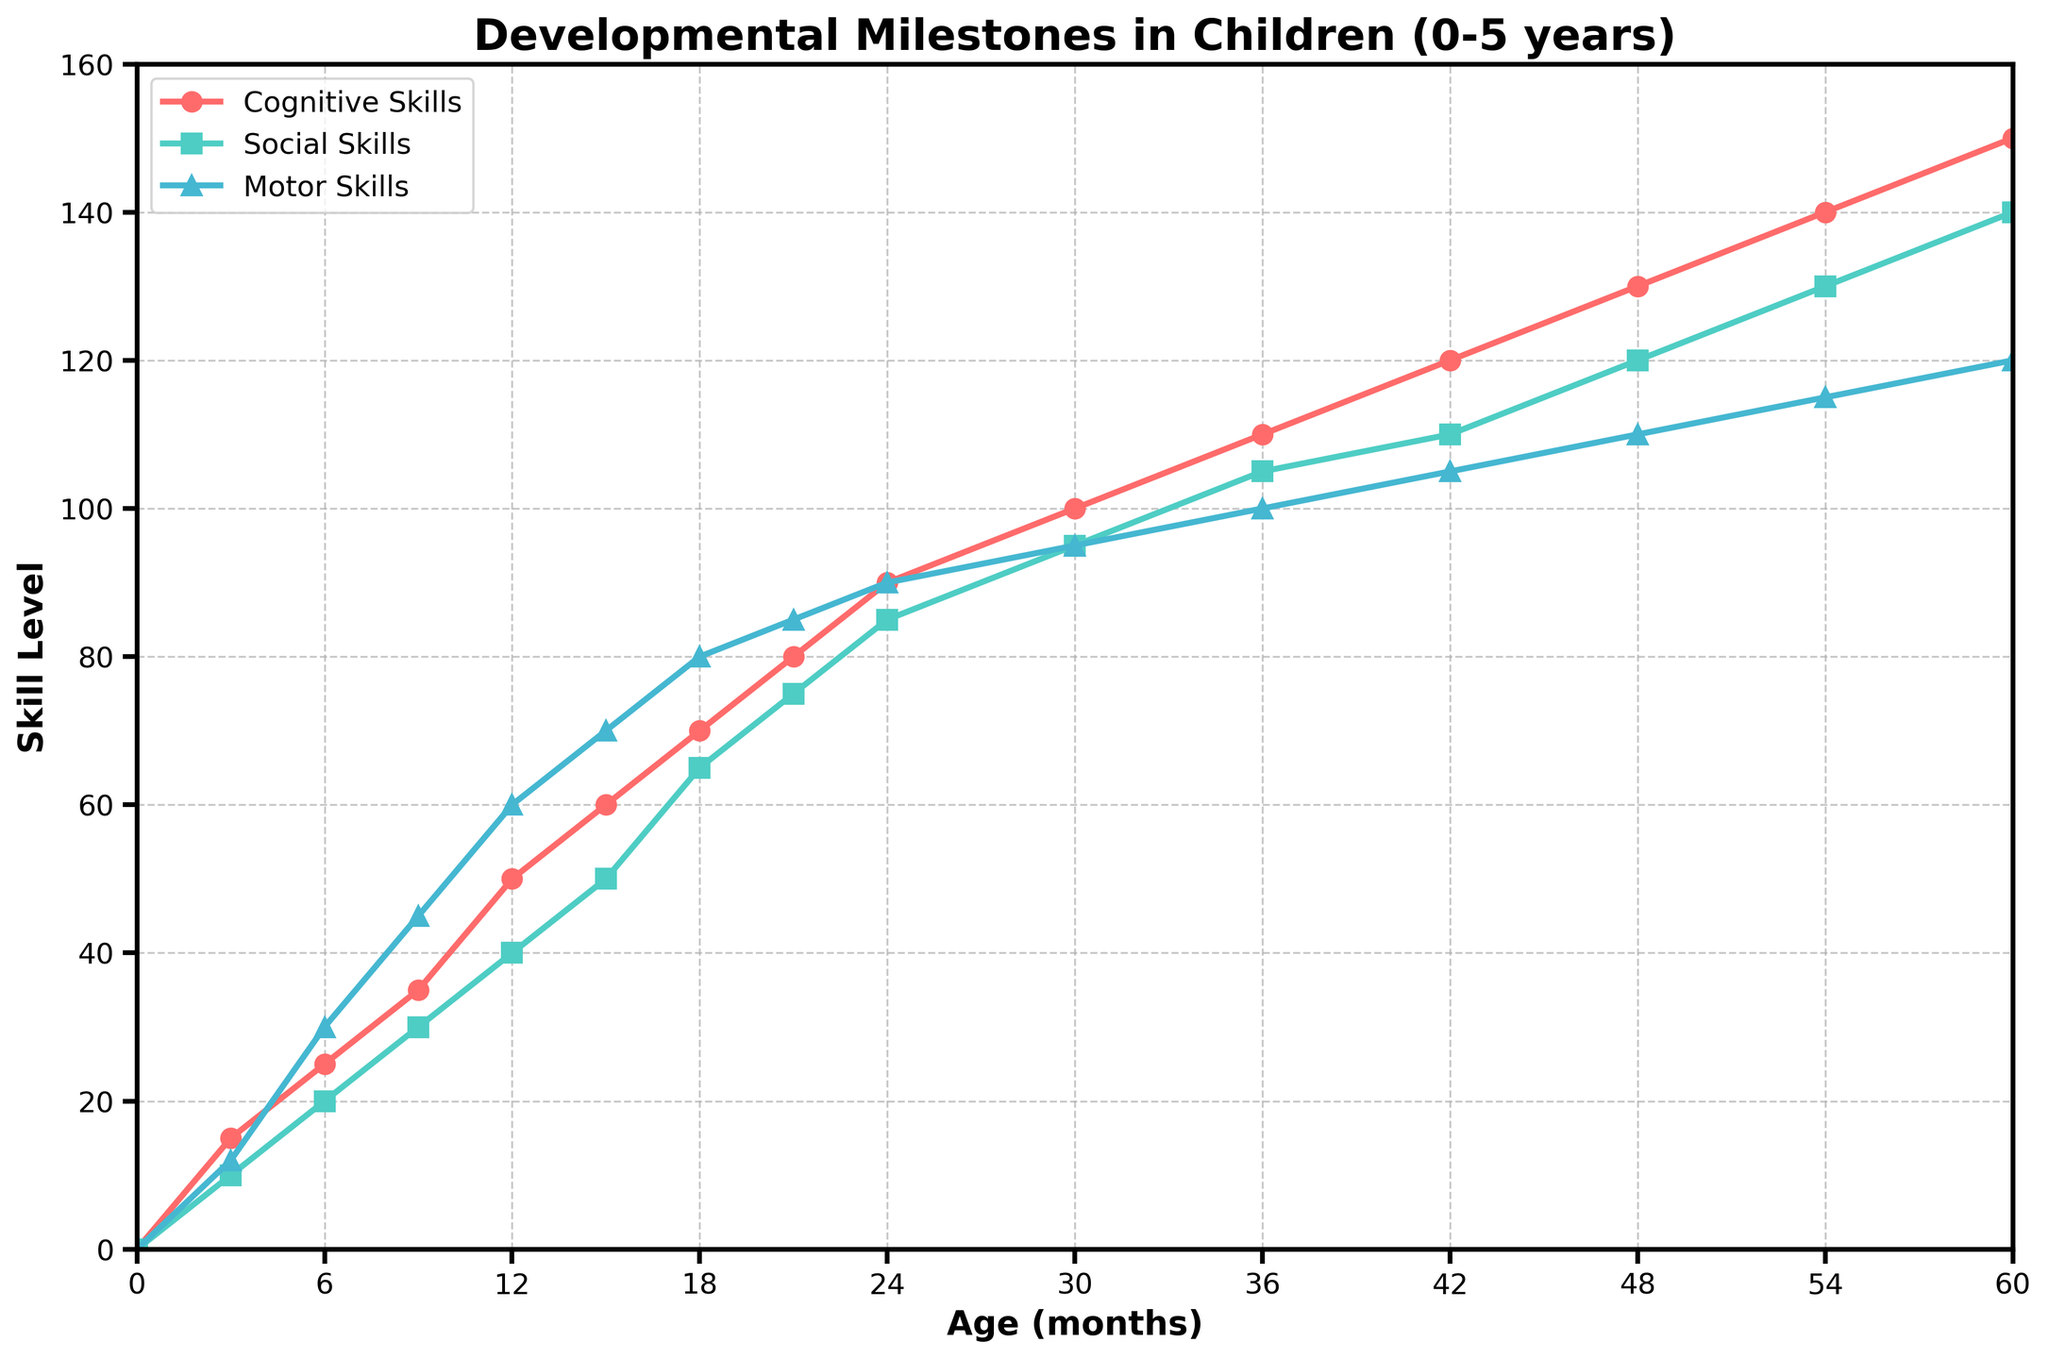What is the skill level of cognitive skills at 24 months? At 24 months, the skill level for cognitive skills can be identified on the y-axis where the line labeled "Cognitive Skills" intersects the 24-month mark on the x-axis.
Answer: 90 How much higher is the cognitive skill level compared to the motor skill level at 54 months? First, identify the cognitive skill level at 54 months (140) and the motor skill level at 54 months (115). Then subtract the motor skill level from the cognitive skill level: 140 - 115 = 25.
Answer: 25 Which skill shows the greatest increase between 12 and 24 months? Find the increase for each skill between 12 and 24 months. Cognitive Skills: 90 - 50 = 40; Social Skills: 85 - 40 = 45; Motor Skills: 90 - 60 = 30. Social skills increased the most by 45 units.
Answer: Social Skills Between which ages does the motor skill level first reach 100? Identify where the motor skills line first intersects the 100 level on the y-axis. It occurs at 36 months.
Answer: 36 months By how much do social skills increase from 0 to 60 months? Find the social skill values at 0 months (0) and 60 months (140) and then calculate the difference: 140 - 0 = 140.
Answer: 140 What is the difference between social and motor skills at 18 months? First, find the social skill level at 18 months (65) and motor skill level at 18 months (80). Then, calculate the difference: 80 - 65 = 15.
Answer: 15 Which skill reaches a level of 110 first, cognitive skills or motor skills? Find the point at which each skill line reaches 110 on the y-axis. Cognitive skills reach it first at 42 months, while motor skills reach it later at 54 months.
Answer: Cognitive Skills What is the trend in social skills development from age 0 to 60 months? Social skills start at 0 and steadily increase, reaching 140 by 60 months. The trend is a consistent upward slope indicating a steady improvement in social skills over time.
Answer: Steady upward trend 